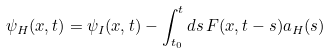Convert formula to latex. <formula><loc_0><loc_0><loc_500><loc_500>\psi _ { H } ( x , t ) = \psi _ { I } ( x , t ) - \int _ { t _ { 0 } } ^ { t } d s \, F ( x , t - s ) a _ { H } ( s )</formula> 